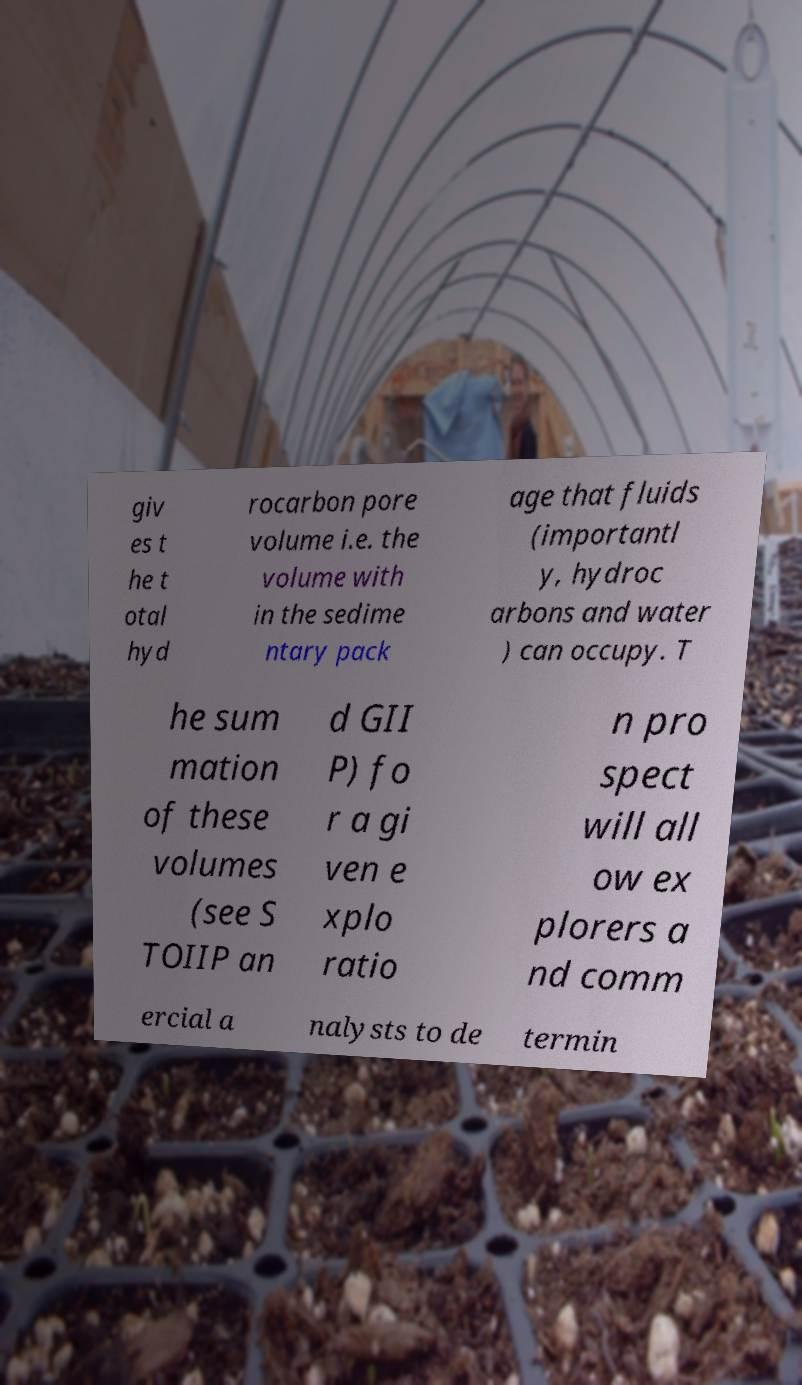What messages or text are displayed in this image? I need them in a readable, typed format. giv es t he t otal hyd rocarbon pore volume i.e. the volume with in the sedime ntary pack age that fluids (importantl y, hydroc arbons and water ) can occupy. T he sum mation of these volumes (see S TOIIP an d GII P) fo r a gi ven e xplo ratio n pro spect will all ow ex plorers a nd comm ercial a nalysts to de termin 